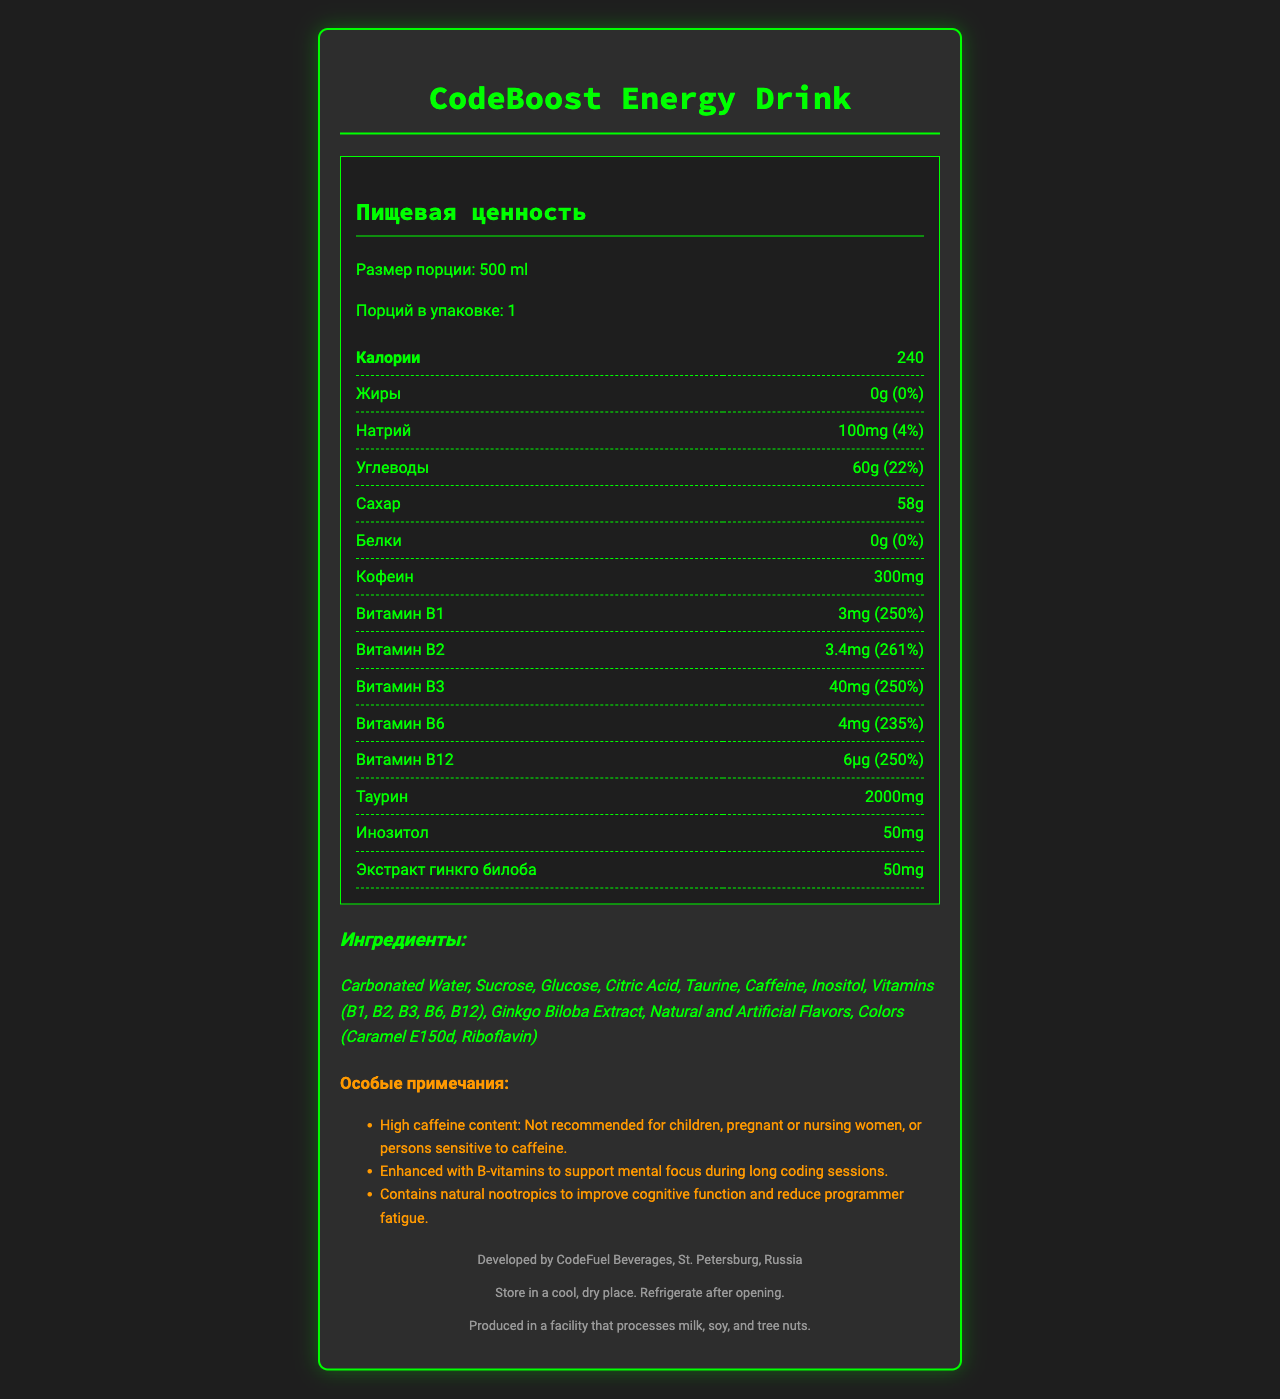what is the serving size of CodeBoost Energy Drink? The serving size is listed as 500 ml on the label.
Answer: 500 ml how many servings are in one container of CodeBoost Energy Drink? According to the label, there is 1 serving per container.
Answer: 1 how many calories are in one serving of CodeBoost Energy Drink? The label indicates that there are 240 calories per serving.
Answer: 240 what is the amount of caffeine in one serving of CodeBoost Energy Drink? The label states that there are 300 mg of caffeine in one serving.
Answer: 300 mg what vitamins are included in CodeBoost Energy Drink? The label lists Vitamins B1, B2, B3, B6, and B12 in the ingredients section.
Answer: Vitamins B1, B2, B3, B6, and B12 which ingredient is present in the largest amount in CodeBoost Energy Drink? A. Sucrose B. Glucose C. Carbonated Water D. Citric Acid The list of ingredients suggests the largest amount is Carbonated Water, as ingredients are usually listed in descending order of quantity.
Answer: C. Carbonated Water what is the percent daily value of sodium in CodeBoost Energy Drink? A. 22% B. 4% C. 250% D. 0% The label states that the sodium content represents 4% of the daily value.
Answer: B. 4% True or False: CodeBoost Energy Drink contains protein. The label indicates that the protein content is 0g.
Answer: False summarize the contents and special notes of the CodeBoost Energy Drink label. The label provides detailed nutritional information, a list of ingredients, allergen information, storage instructions, and special notes about usage warnings and intended benefits.
Answer: CodeBoost Energy Drink provides a nutritional profile consisting of 240 calories per 500 ml serving, no fat, 100 mg of sodium, 60 g of carbohydrates with 58 g of sugars, 0 g of protein, and 300 mg of caffeine. It contains high levels of B-vitamins (B1, B2, B3, B6, B12), taurine, inositol, and ginkgo biloba extract. It is recommended for enhancing mental focus and cognitive function during long coding sessions, but is not suitable for children, pregnant or nursing women, or individuals sensitive to caffeine. how many grams of taurine are in CodeBoost Energy Drink? The label specifies that there are 2000 mg of taurine in the drink.
Answer: 2000 mg what is the percentage of daily value for Vitamin B6 in CodeBoost Energy Drink? The label shows that the daily value percentage for Vitamin B6 is 235%.
Answer: 235% what is the purpose of adding B-vitamins to CodeBoost Energy Drink? According to the label, B-vitamins are included to help support mental focus during long coding sessions.
Answer: To support mental focus during long coding sessions what color additives are listed in the ingredients of CodeBoost Energy Drink? The color additives mentioned in the ingredients are Caramel E150d and Riboflavin.
Answer: Caramel E150d, Riboflavin where is CodeBoost Energy Drink manufactured? The manufacturer information on the label states that the drink is developed by CodeFuel Beverages in St. Petersburg, Russia.
Answer: St. Petersburg, Russia is there any information about the recycling instructions for CodeBoost Energy Drink? The label provided does not include any information on recycling instructions.
Answer: Not enough information 